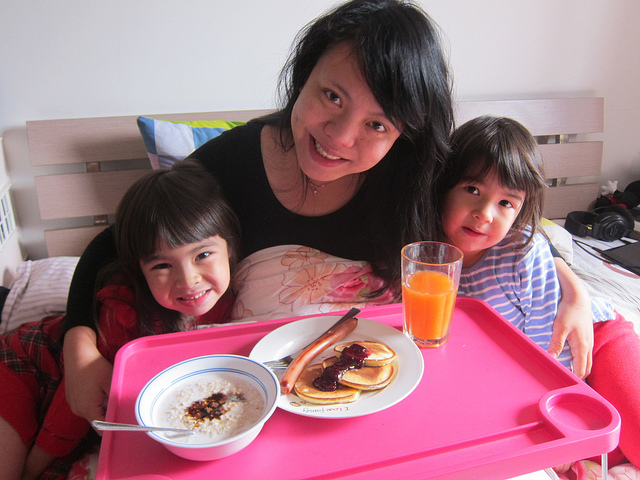Can you describe the setting in which the people are present? The individuals are situated in a homely domestic environment, likely a dining area or a bedroom adapted for a casual meal. There is a pink tray with breakfast items, including pancakes and a bowl of oatmeal. The presence of a camera in the background suggests that capturing moments like these is valued in this setting. 